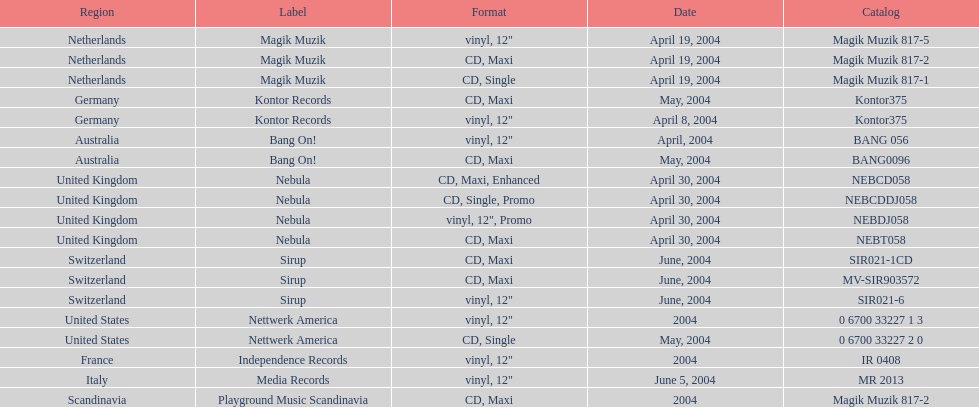How many catalogs were released? 19. 